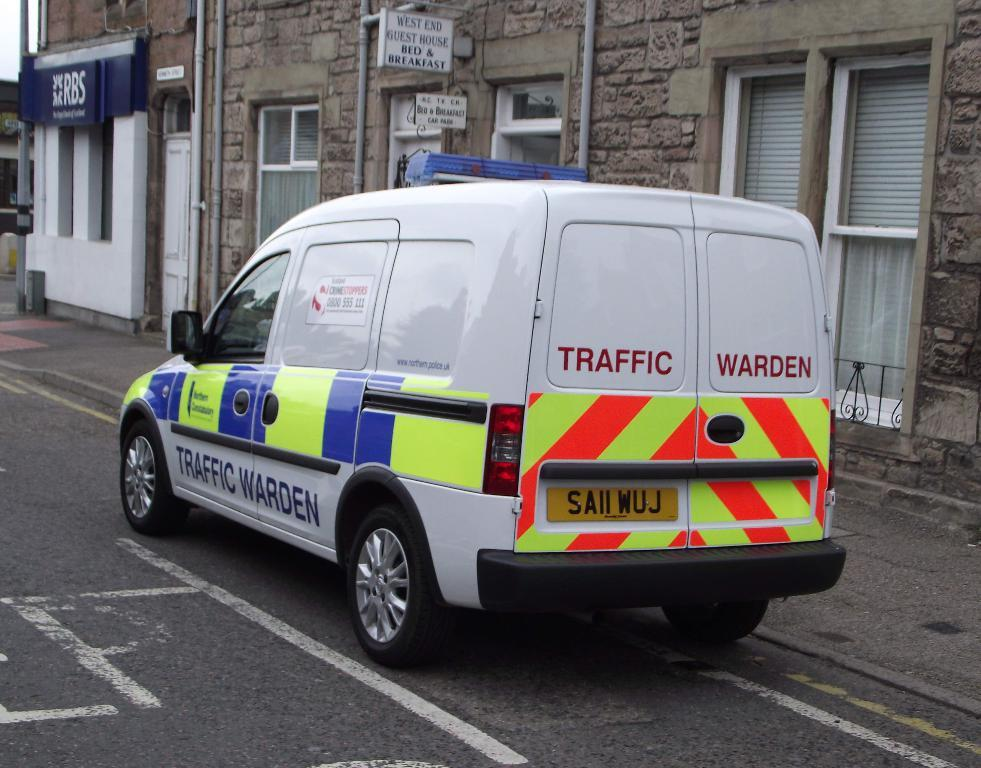<image>
Provide a brief description of the given image. A traffic warden van has brightly colored stripes on it. 